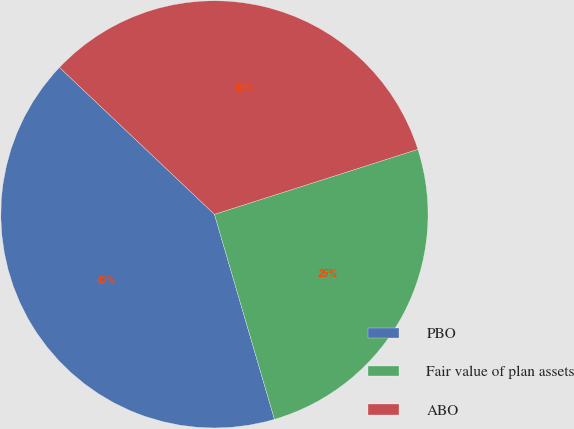Convert chart to OTSL. <chart><loc_0><loc_0><loc_500><loc_500><pie_chart><fcel>PBO<fcel>Fair value of plan assets<fcel>ABO<nl><fcel>41.61%<fcel>25.39%<fcel>33.0%<nl></chart> 